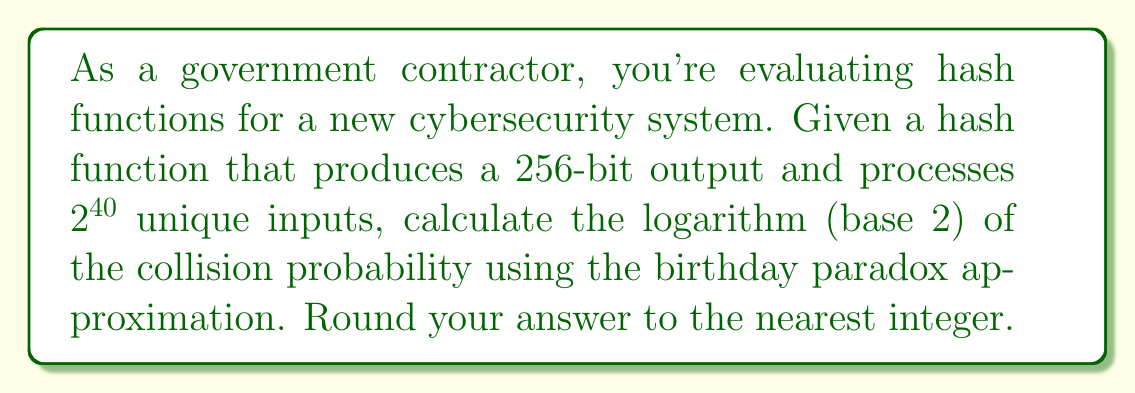Provide a solution to this math problem. Let's approach this step-by-step:

1) The birthday paradox approximation for collision probability in hash functions is given by:

   $$P(collision) \approx \frac{n^2}{2m}$$

   Where $n$ is the number of inputs and $m$ is the number of possible outputs.

2) In this case:
   $n = 2^{40}$ (number of unique inputs)
   $m = 2^{256}$ (number of possible outputs for a 256-bit hash)

3) Substituting these values:

   $$P(collision) \approx \frac{(2^{40})^2}{2 \cdot 2^{256}} = \frac{2^{80}}{2^{257}} = 2^{80-257} = 2^{-177}$$

4) To find the logarithm (base 2) of this probability:

   $$\log_2(P(collision)) \approx \log_2(2^{-177}) = -177$$

5) The question asks for the nearest integer, which is already -177.
Answer: $-177$ 